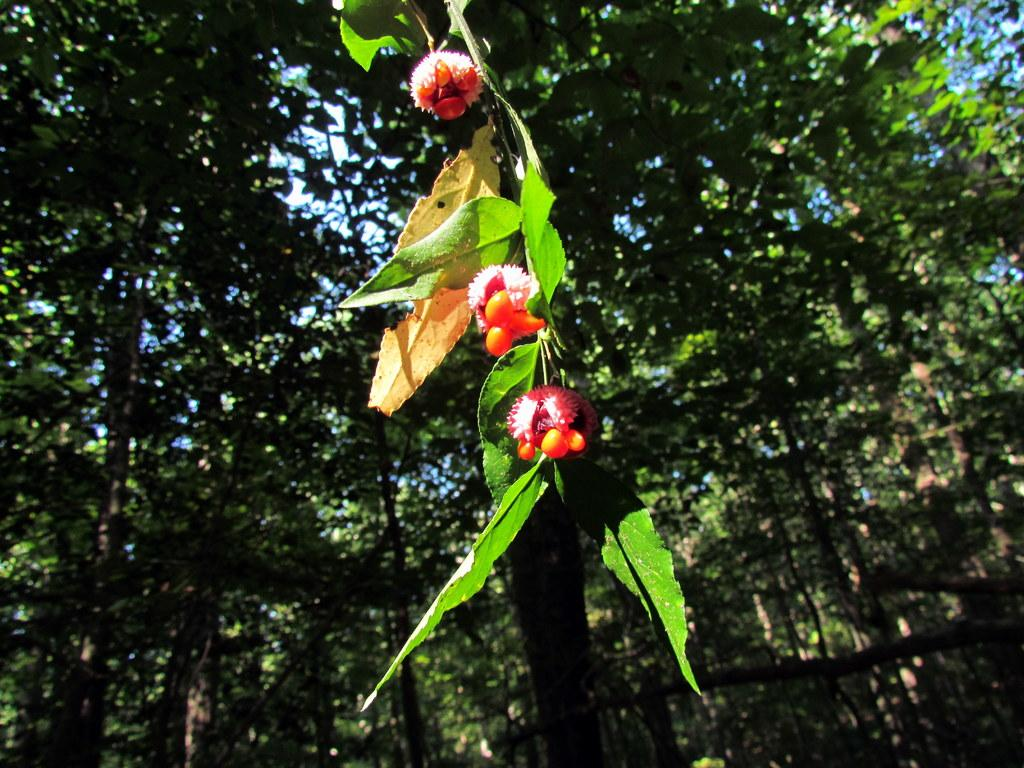What type of living organisms can be seen on the plant in the image? There are fruits on a plant in the image. What can be seen in the background of the image? There are trees visible in the background of the image. Where is the library located in the image? There is no library present in the image. What type of health benefits can be gained from consuming the fruits in the image? The image does not provide information about the specific fruits or their health benefits. 